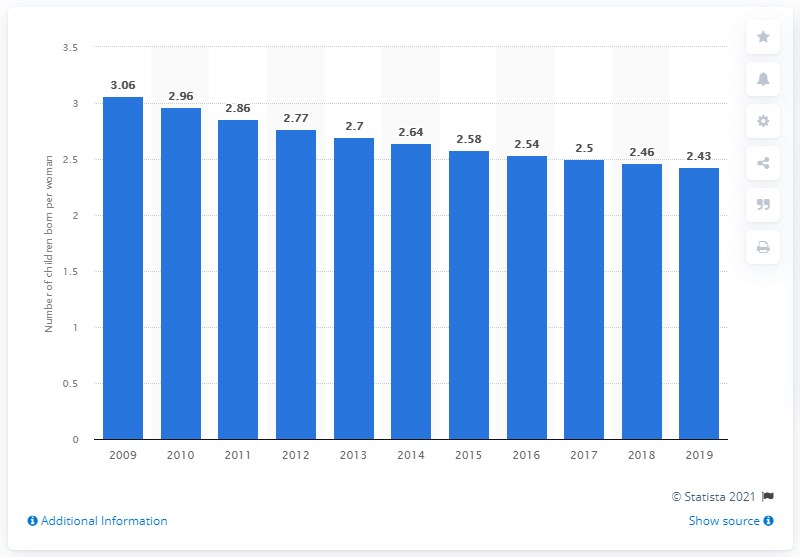Identify some key points in this picture. The fertility rate in Honduras in 2019 was 2.43 children per woman. 